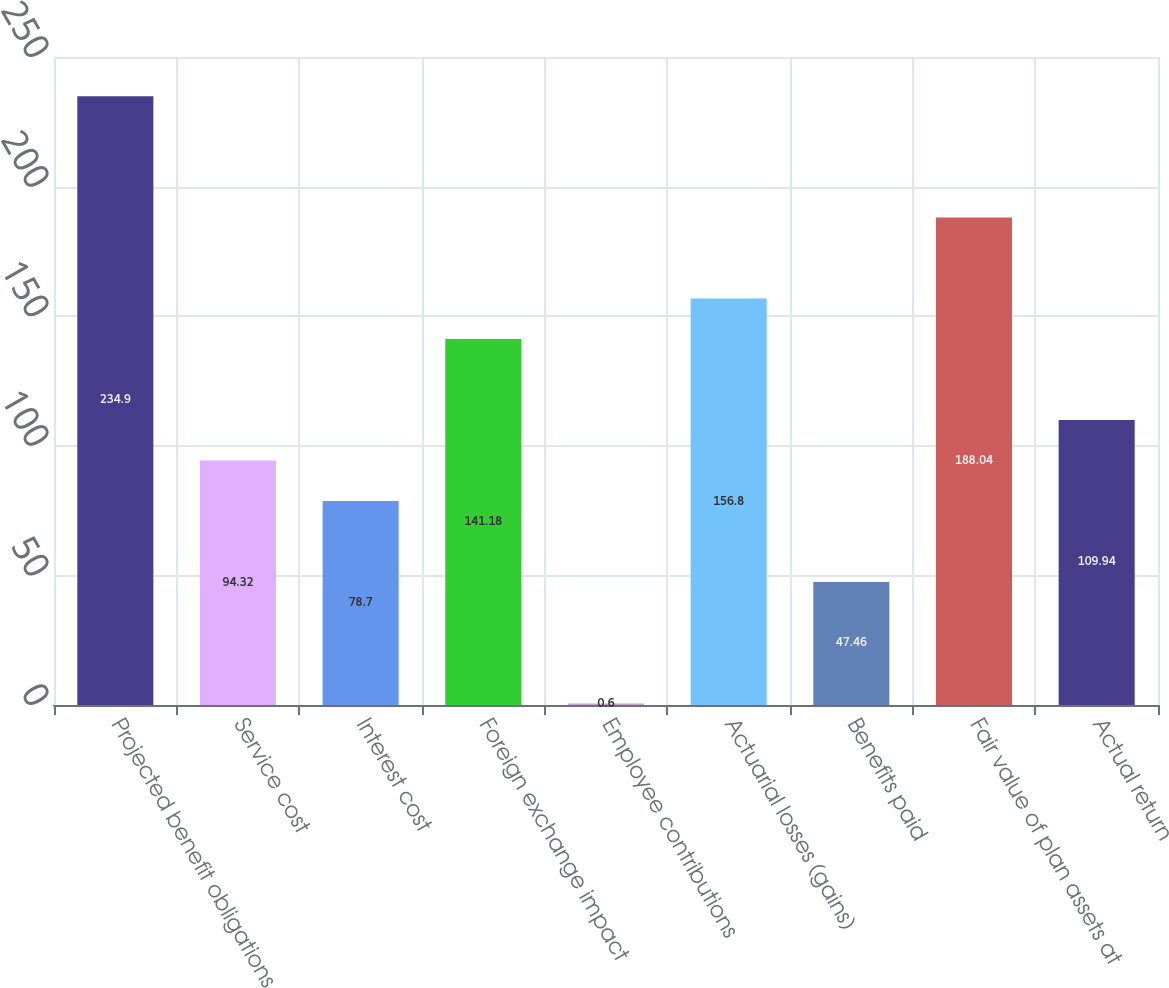<chart> <loc_0><loc_0><loc_500><loc_500><bar_chart><fcel>Projected benefit obligations<fcel>Service cost<fcel>Interest cost<fcel>Foreign exchange impact<fcel>Employee contributions<fcel>Actuarial losses (gains)<fcel>Benefits paid<fcel>Fair value of plan assets at<fcel>Actual return<nl><fcel>234.9<fcel>94.32<fcel>78.7<fcel>141.18<fcel>0.6<fcel>156.8<fcel>47.46<fcel>188.04<fcel>109.94<nl></chart> 